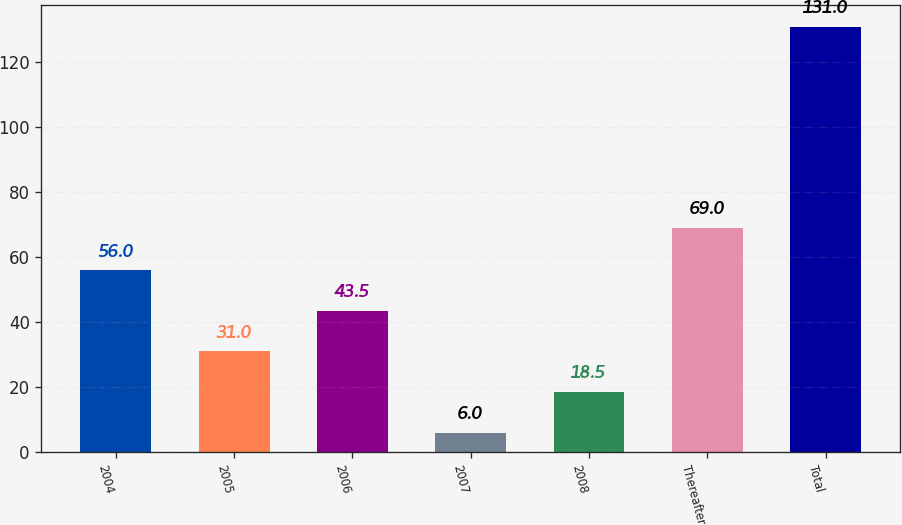Convert chart. <chart><loc_0><loc_0><loc_500><loc_500><bar_chart><fcel>2004<fcel>2005<fcel>2006<fcel>2007<fcel>2008<fcel>Thereafter<fcel>Total<nl><fcel>56<fcel>31<fcel>43.5<fcel>6<fcel>18.5<fcel>69<fcel>131<nl></chart> 